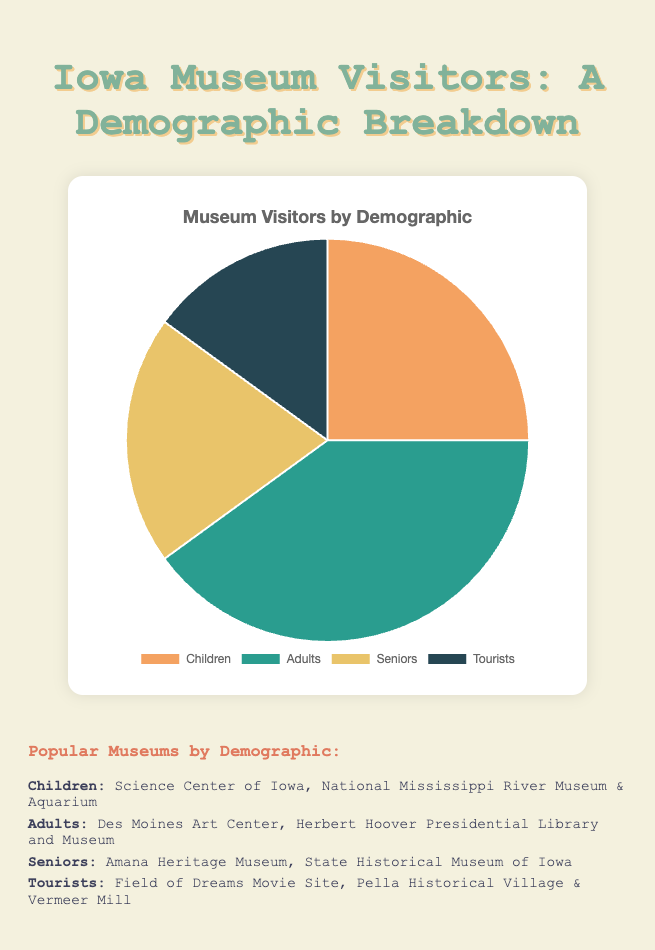How many more adults visit local museums compared to tourists? We need to find the difference in the percentage of adults and tourists. The percentage of adults is 40%, and the percentage of tourists is 15%. Therefore, the difference is 40% - 15% = 25%.
Answer: 25% What percentage of museum visitors are either children or seniors? To find the combined percentage of children and seniors, we add their individual percentages. Children are 25% and seniors are 20%, so 25% + 20% = 45%.
Answer: 45% Which demographic category has the smallest representation among Iowa museum visitors? From the pie chart data, we can see the percentages: Children (25%), Adults (40%), Seniors (20%), and Tourists (15%). The smallest percentage is for Tourists at 15%.
Answer: Tourists By how much does the percentage of children visitors differ from the percentage of seniors visitors? To find the difference between the percentage of children and seniors, we subtract the smaller percentage from the larger one. Children are 25% and seniors are 20%, so 25% - 20% = 5%.
Answer: 5% What is the color used to represent Adults in the pie chart? From the pie chart, the color used for Adults is identified by the segment representing 40% of the total. The provided colors in the code indicate Adults are represented by green.
Answer: Green If we combined the percentages of seniors and tourists, would their total be greater or less than the percentage of adults? To determine this, we add the percentages of seniors and tourists and compare it to the percentage of adults. Seniors are 20%, and tourists are 15%, so their combined percentage is 20% + 15% = 35%. The percentage of adults is 40%, so 35% is less than 40%.
Answer: Less Which demographic has a higher percentage: Children or Seniors? By directly comparing their percentages: Children (25%) and Seniors (20%), we see that Children have a higher percentage.
Answer: Children How much greater is the percentage of Adults compared to Seniors? To find this, subtract the percentage of seniors from the percentage of adults. Adults are 40%, and seniors are 20%, so 40% - 20% = 20%.
Answer: 20% 